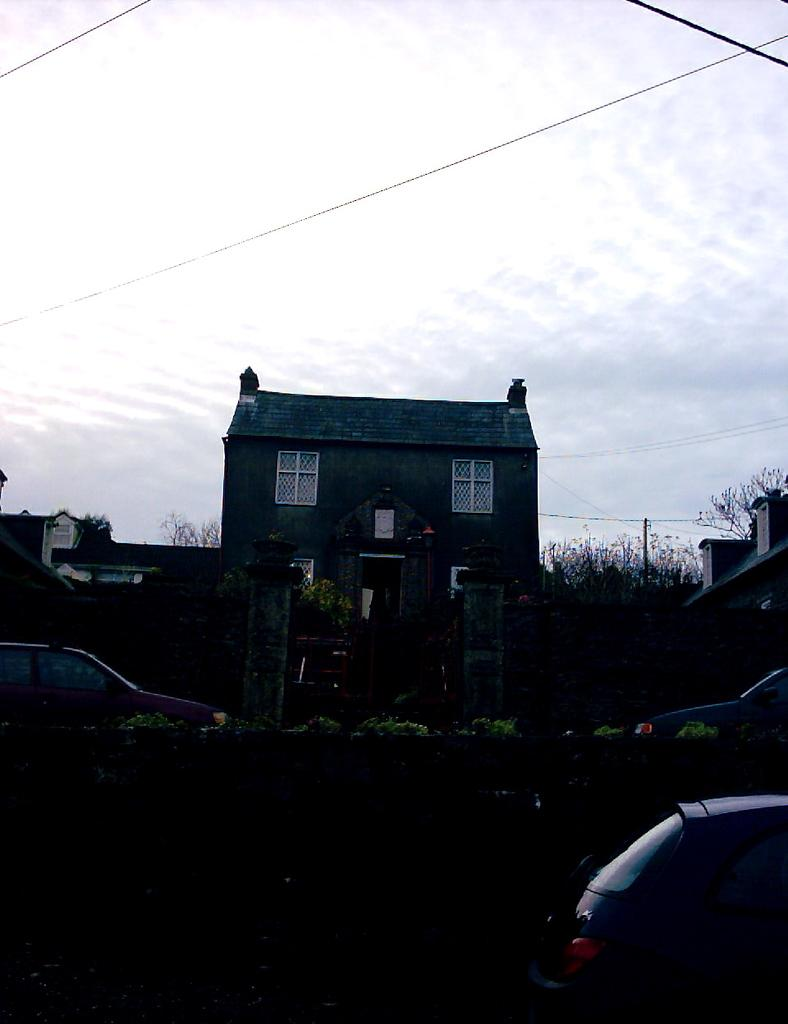What structure is present in the image? There is a building in the image. Where is the first car located in the image? The first car is on the left side of the image. Where is the second car located in the image? The second car is on the bottom right side of the image. What is visible at the top of the image? The sky is visible at the top of the image. What type of bushes can be seen growing around the building in the image? There are no bushes visible in the image; only the building, cars, and sky are present. Can you see a cow grazing near the building in the image? There is no cow present in the image. 